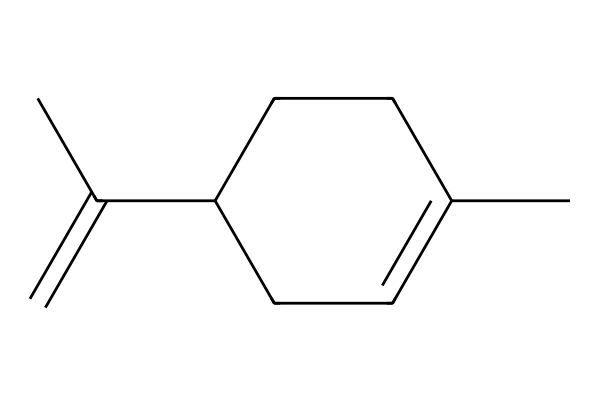What is the common name of this chemical? The provided SMILES represents limonene, which is commonly recognized for its citrus scent.
Answer: limonene How many carbon atoms are in limonene? Analyzing the structure reveals there are ten carbon atoms in total.
Answer: 10 What type of compound is limonene? Limonene is classified as a monoterpene due to its two isoprene units.
Answer: monoterpene How many double bonds are present in limonene? By examining the structure, there are two double bonds indicated in the chemical structure.
Answer: 2 Which part of the structure indicates that limonene is a cyclic compound? The presence of a cyclic arrangement is shown by the 'C1' notation, indicating a ring structure.
Answer: ring What functional group is typically associated with limonene’s scent? Limonene is associated with the presence of a hydrocarbon functional group, particularly alkenes due to its double bonds.
Answer: alkene Why is limonene considered an important compound in cleaning products? Limonene's ability to dissolve oils and its pleasant fragrance make it effective in cleaning products.
Answer: dissolves oils 